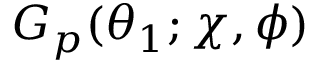<formula> <loc_0><loc_0><loc_500><loc_500>G _ { p } ( \theta _ { 1 } ; \chi , \phi )</formula> 